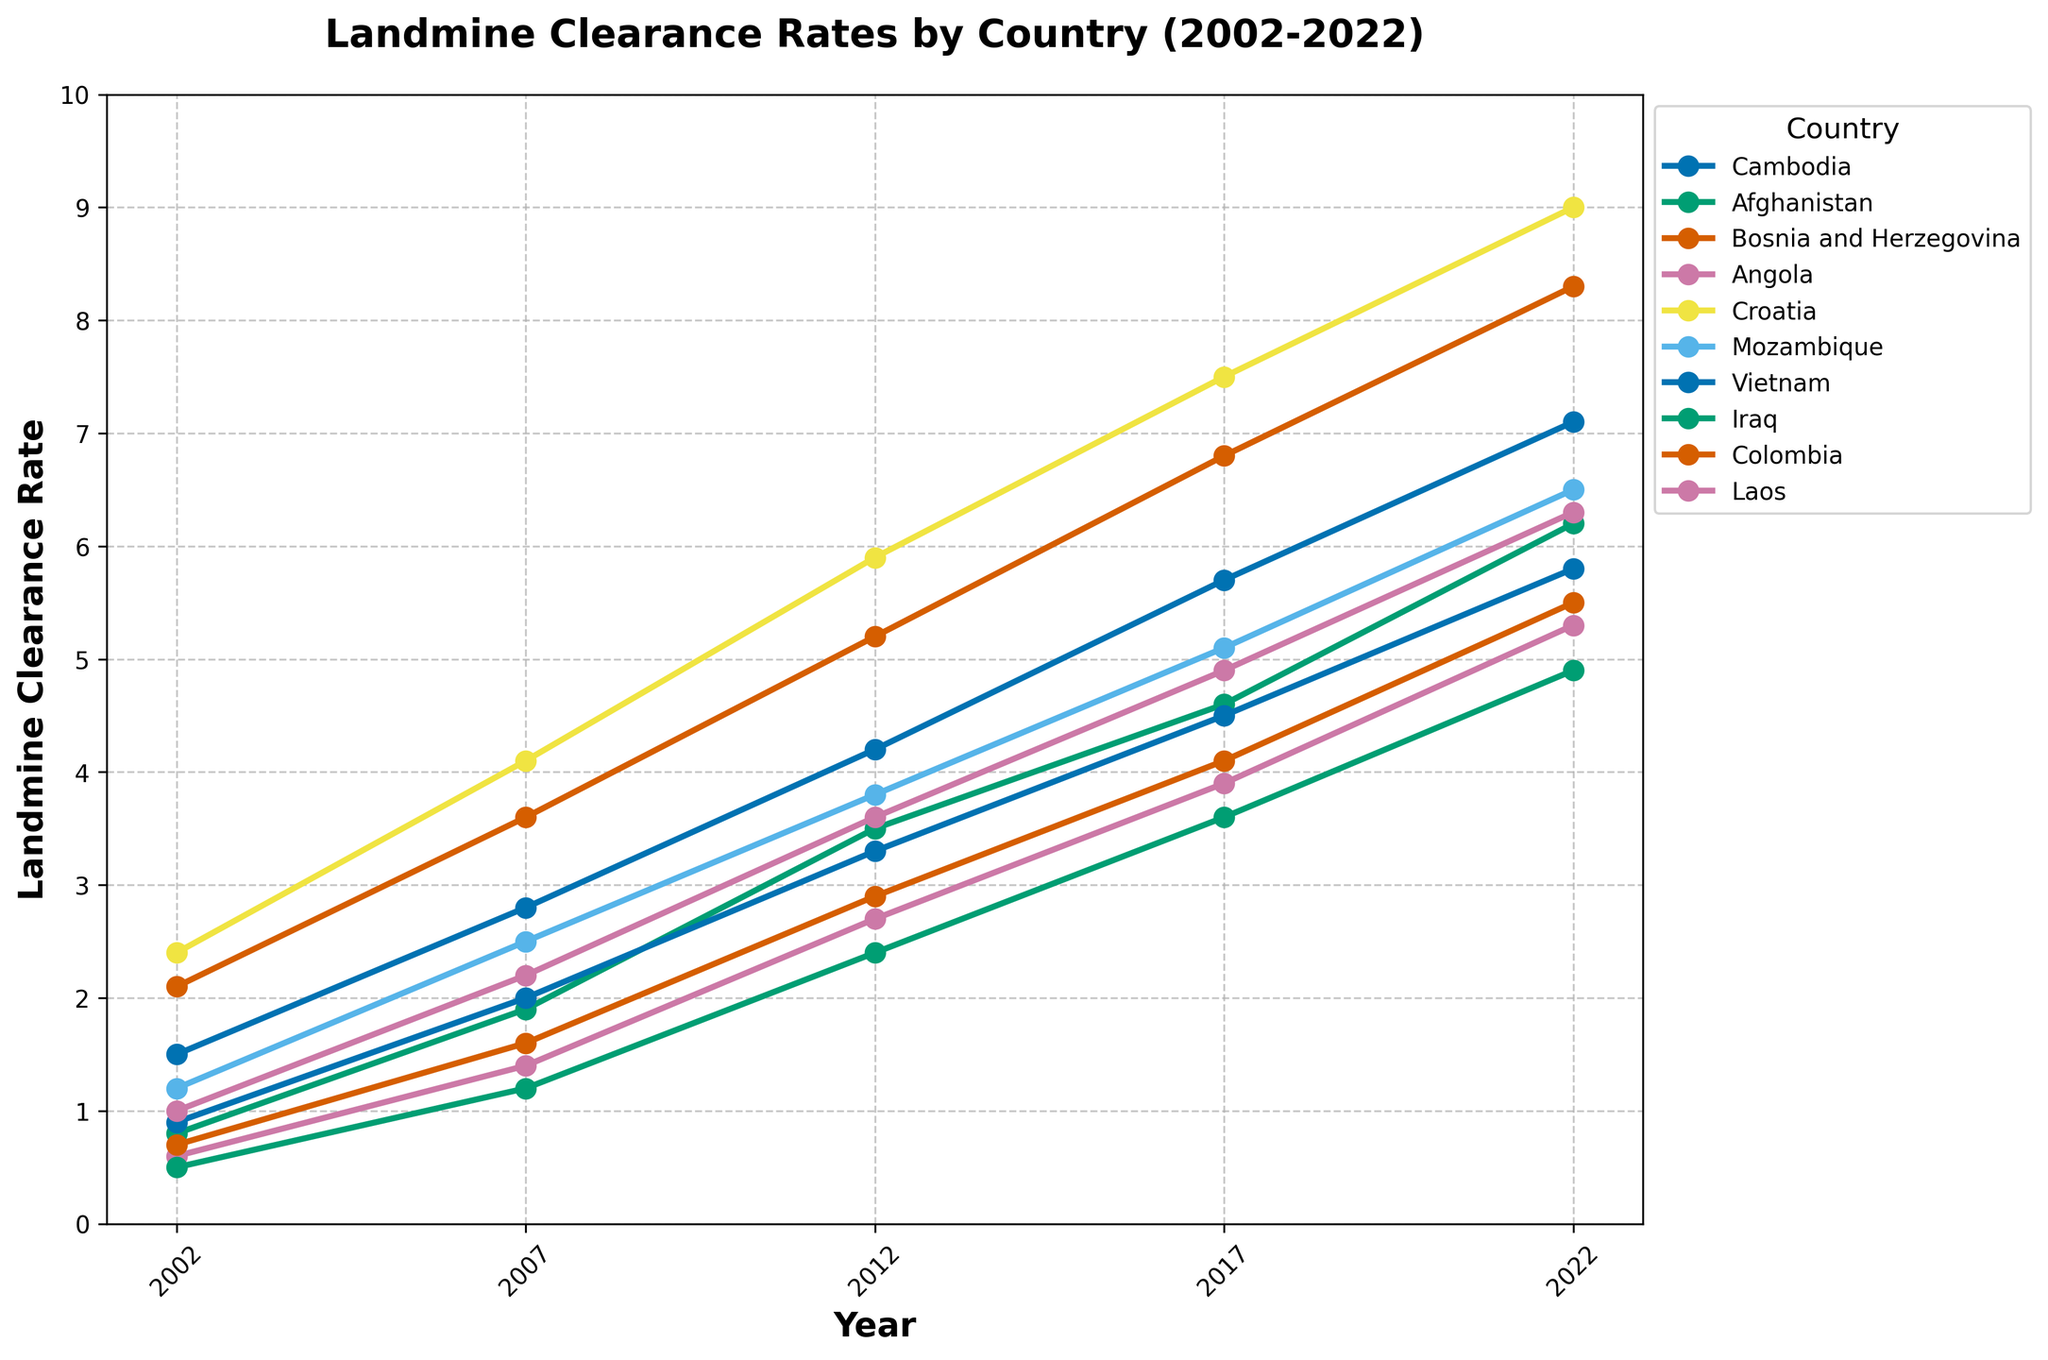What country shows the highest landmine clearance rate in 2022? By observing the height/length of the lines in the year 2022, Bosnia and Herzegovina is at the highest point, indicating that it has the highest landmine clearance rate for that year.
Answer: Bosnia and Herzegovina Which countries have shown consistent growth in landmine clearance rates over the 20-year period? By examining each country's line from 2002 to 2022, we can see that all the countries listed show consistent growth, as all their lines are inclining upwards without any dips or plateaus.
Answer: All listed countries Between which two years did Angola see the highest increase in landmine clearance rate? By looking at the slope (steepness) of Angola's line between consecutive years, the steepest segment appears between 2012 and 2017. This indicates the highest rate of increase.
Answer: 2012 and 2017 Which country had the lowest clearance rate in 2007? By examining the height/length of the lines at the year 2007, Iraq's line is the lowest, suggesting Iraq had the lowest landmine clearance rate in that year.
Answer: Iraq Compare the clearance rates of Croatia and Cambodia in 2012. Which country had a higher rate, and by how much? By looking at the points for Croatia and Cambodia in 2012, Croatia is at 5.9 while Cambodia is at 4.2. The difference is \(5.9 - 4.2 = 1.7\). Therefore, Croatia had a higher rate by 1.7.
Answer: Croatia by 1.7 Which two countries had nearly the same landmine clearance rate in 2022? By observing the points for the year 2022, Laos and Afghanistan have rates that are very close to each other (6.3 and 6.2 respectively).
Answer: Laos and Afghanistan What is the average landmine clearance rate for Mozambique from 2002 to 2022? To find the average, sum the values for Mozambique (1.2 + 2.5 + 3.8 + 5.1 + 6.5 = 19.1) and then divide by the number of years (5). Thus, the average is \(19.1 / 5 = 3.82\).
Answer: 3.82 Which country had the smallest increase in landmine clearance rate from 2002 to 2007? By observing the differences between 2002 and 2007 for each country, the smallest increase is evident for Iraq, which increased from 0.5 to 1.2 (an increase of 0.7).
Answer: Iraq Find the difference in the clearance rate of Vietnam between 2002 and 2022. Vietnam's clearance rate in 2002 was 0.9 and in 2022 it was 5.8. The difference is \(5.8 - 0.9 = 4.9\).
Answer: 4.9 Which country had a larger clearance rate in 2017, Mozambique or Vietnam? By comparing their points in 2017, Mozambique is at 5.1 while Vietnam is at 4.5. Mozambique had a larger rate.
Answer: Mozambique 